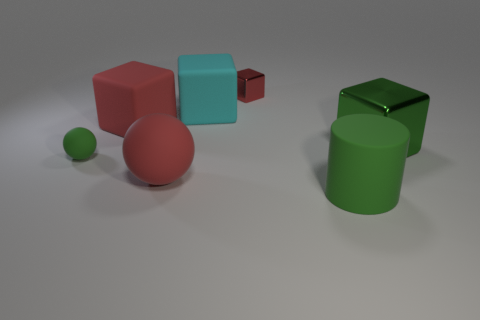There is a big rubber cylinder; are there any big cyan objects behind it?
Ensure brevity in your answer.  Yes. How many large green metallic things are the same shape as the cyan object?
Your answer should be very brief. 1. Is the material of the large cylinder the same as the tiny thing that is in front of the green metallic block?
Offer a very short reply. Yes. How many balls are there?
Your answer should be very brief. 2. How big is the rubber cube that is to the left of the big cyan cube?
Your answer should be compact. Large. How many cyan cubes have the same size as the rubber cylinder?
Your answer should be compact. 1. There is a thing that is both in front of the green metal block and right of the small metallic object; what is its material?
Offer a very short reply. Rubber. There is a green cylinder that is the same size as the cyan block; what is its material?
Give a very brief answer. Rubber. There is a red cube on the right side of the large rubber block that is left of the ball in front of the tiny green rubber sphere; what size is it?
Offer a terse response. Small. What size is the green object that is the same material as the cylinder?
Make the answer very short. Small. 